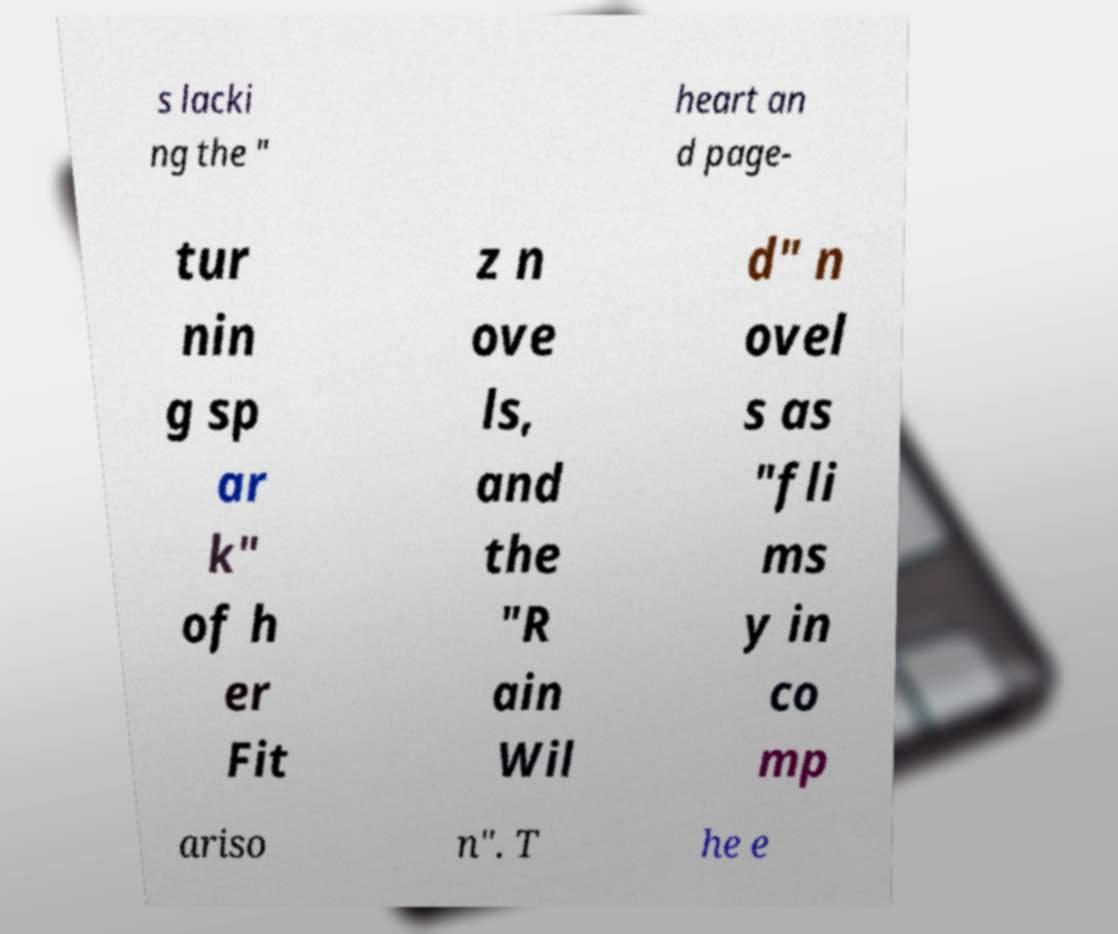Please read and relay the text visible in this image. What does it say? s lacki ng the " heart an d page- tur nin g sp ar k" of h er Fit z n ove ls, and the "R ain Wil d" n ovel s as "fli ms y in co mp ariso n". T he e 